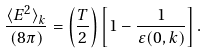<formula> <loc_0><loc_0><loc_500><loc_500>\frac { { \langle E ^ { 2 } \rangle } _ { k } } { ( 8 \pi ) } = \left ( \frac { T } { 2 } \right ) \left [ 1 - \frac { 1 } { \varepsilon ( 0 , k ) } \right ] .</formula> 